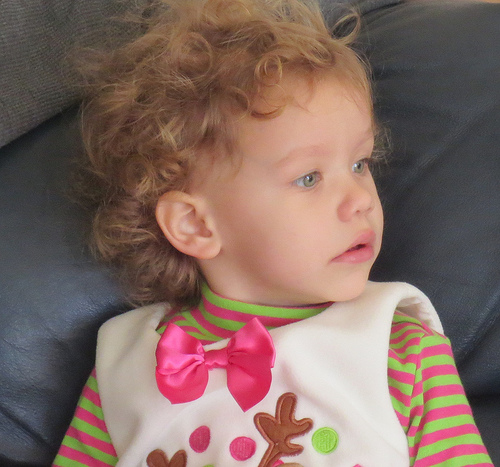<image>
Is there a girl next to the bow? No. The girl is not positioned next to the bow. They are located in different areas of the scene. 